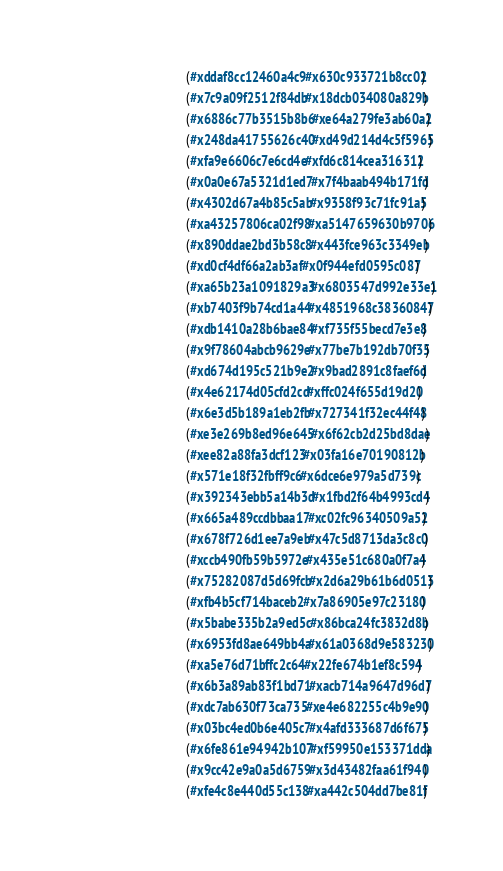Convert code to text. <code><loc_0><loc_0><loc_500><loc_500><_Lisp_>                                     (#xddaf8cc12460a4c9 #x630c933721b8cc02)
                                     (#x7c9a09f2512f84db #x18dcb034080a829b)
                                     (#x6886c77b3515b8b6 #xe64a279fe3ab60a2)
                                     (#x248da41755626c40 #xd49d214d4c5f5965)
                                     (#xfa9e6606c7e6cd4e #xfd6c814cea316312)
                                     (#x0a0e67a5321d1ed7 #x7f4baab494b171fd)
                                     (#x4302d67a4b85c5ab #x9358f93c71fc91a5)
                                     (#xa43257806ca02f98 #xa5147659630b9706)
                                     (#x890ddae2bd3b58c8 #x443fce963c3349eb)
                                     (#xd0cf4df66a2ab3af #x0f944efd0595c087)
                                     (#xa65b23a1091829a3 #x6803547d992e33e1)
                                     (#xb7403f9b74cd1a44 #x4851968c38360847)
                                     (#xdb1410a28b6bae84 #xf735f55becd7e3e8)
                                     (#x9f78604abcb9629e #x77be7b192db70f35)
                                     (#xd674d195c521b9e2 #x9bad2891c8faef6d)
                                     (#x4e62174d05cfd2cd #xffc024f655d19d20)
                                     (#x6e3d5b189a1eb2fb #x727341f32ec44f48)
                                     (#xe3e269b8ed96e645 #x6f62cb2d25bd8dae)
                                     (#xee82a88fa3dcf123 #x03fa16e70190812b)
                                     (#x571e18f32fbff9c6 #x6dce6e979a5d739c)
                                     (#x392343ebb5a14b3d #x1fbd2f64b4993cd4)
                                     (#x665a489ccdbbaa17 #xc02fc96340509a52)
                                     (#x678f726d1ee7a9eb #x47c5d8713da3c8c0)
                                     (#xccb490fb59b5972e #x435e51c680a0f7a4)
                                     (#x75282087d5d69fcb #x2d6a29b61b6d0513)
                                     (#xfb4b5cf714baceb2 #x7a86905e97c23180)
                                     (#x5babe335b2a9ed5c #x86bca24fc3832d8b)
                                     (#x6953fd8ae649bb4a #x61a0368d9e583230)
                                     (#xa5e76d71bffc2c64 #x22fe674b1ef8c594)
                                     (#x6b3a89ab83f1bd71 #xacb714a9647d96d7)
                                     (#xdc7ab630f73ca735 #xe4e682255c4b9e90)
                                     (#x03bc4ed0b6e405c7 #x4afd333687d6f675)
                                     (#x6fe861e94942b107 #xf59950e153371dda)
                                     (#x9cc42e9a0a5d6759 #x3d43482faa61f940)
                                     (#xfe4c8e440d55c138 #xa442c504dd7be81f)</code> 